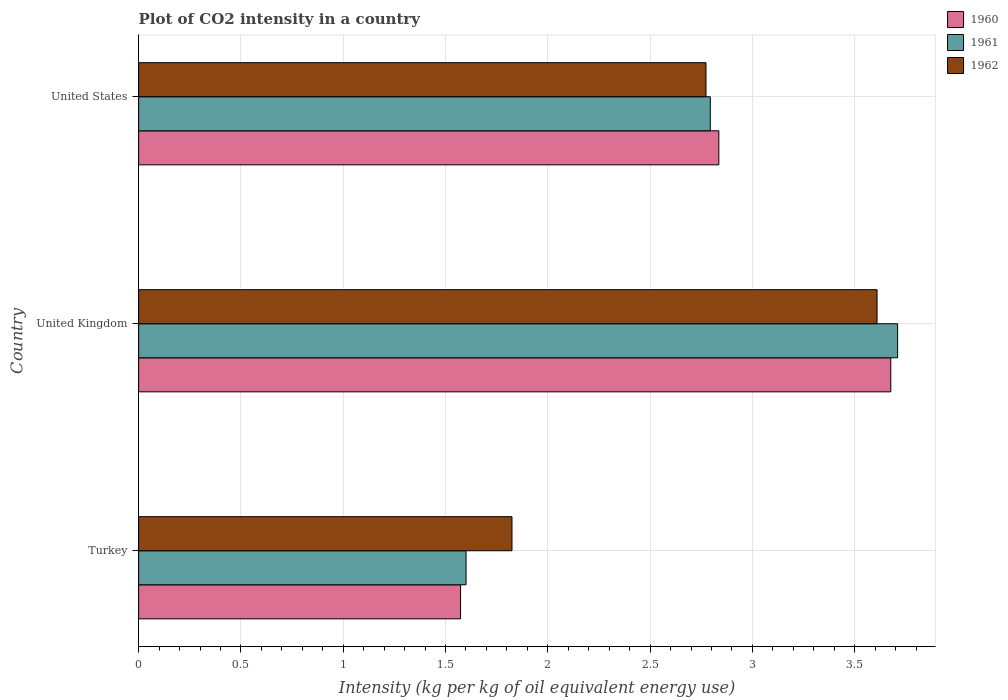How many different coloured bars are there?
Make the answer very short. 3. How many bars are there on the 3rd tick from the top?
Offer a very short reply. 3. In how many cases, is the number of bars for a given country not equal to the number of legend labels?
Make the answer very short. 0. What is the CO2 intensity in in 1961 in United States?
Ensure brevity in your answer.  2.79. Across all countries, what is the maximum CO2 intensity in in 1960?
Your answer should be compact. 3.68. Across all countries, what is the minimum CO2 intensity in in 1962?
Provide a succinct answer. 1.82. In which country was the CO2 intensity in in 1961 maximum?
Make the answer very short. United Kingdom. In which country was the CO2 intensity in in 1961 minimum?
Offer a very short reply. Turkey. What is the total CO2 intensity in in 1961 in the graph?
Give a very brief answer. 8.1. What is the difference between the CO2 intensity in in 1960 in United Kingdom and that in United States?
Give a very brief answer. 0.84. What is the difference between the CO2 intensity in in 1960 in United States and the CO2 intensity in in 1961 in Turkey?
Offer a very short reply. 1.24. What is the average CO2 intensity in in 1961 per country?
Make the answer very short. 2.7. What is the difference between the CO2 intensity in in 1960 and CO2 intensity in in 1962 in United Kingdom?
Ensure brevity in your answer.  0.07. What is the ratio of the CO2 intensity in in 1960 in Turkey to that in United Kingdom?
Give a very brief answer. 0.43. Is the CO2 intensity in in 1962 in United Kingdom less than that in United States?
Offer a very short reply. No. What is the difference between the highest and the second highest CO2 intensity in in 1961?
Your answer should be very brief. 0.92. What is the difference between the highest and the lowest CO2 intensity in in 1960?
Give a very brief answer. 2.1. In how many countries, is the CO2 intensity in in 1961 greater than the average CO2 intensity in in 1961 taken over all countries?
Give a very brief answer. 2. Is the sum of the CO2 intensity in in 1960 in Turkey and United Kingdom greater than the maximum CO2 intensity in in 1962 across all countries?
Make the answer very short. Yes. What does the 2nd bar from the bottom in Turkey represents?
Your answer should be very brief. 1961. What is the difference between two consecutive major ticks on the X-axis?
Keep it short and to the point. 0.5. Does the graph contain any zero values?
Your answer should be very brief. No. How many legend labels are there?
Your response must be concise. 3. How are the legend labels stacked?
Your answer should be compact. Vertical. What is the title of the graph?
Make the answer very short. Plot of CO2 intensity in a country. Does "1967" appear as one of the legend labels in the graph?
Provide a short and direct response. No. What is the label or title of the X-axis?
Offer a very short reply. Intensity (kg per kg of oil equivalent energy use). What is the label or title of the Y-axis?
Provide a short and direct response. Country. What is the Intensity (kg per kg of oil equivalent energy use) in 1960 in Turkey?
Give a very brief answer. 1.57. What is the Intensity (kg per kg of oil equivalent energy use) of 1961 in Turkey?
Give a very brief answer. 1.6. What is the Intensity (kg per kg of oil equivalent energy use) in 1962 in Turkey?
Your answer should be compact. 1.82. What is the Intensity (kg per kg of oil equivalent energy use) of 1960 in United Kingdom?
Offer a very short reply. 3.68. What is the Intensity (kg per kg of oil equivalent energy use) in 1961 in United Kingdom?
Your answer should be very brief. 3.71. What is the Intensity (kg per kg of oil equivalent energy use) in 1962 in United Kingdom?
Keep it short and to the point. 3.61. What is the Intensity (kg per kg of oil equivalent energy use) of 1960 in United States?
Offer a very short reply. 2.84. What is the Intensity (kg per kg of oil equivalent energy use) of 1961 in United States?
Make the answer very short. 2.79. What is the Intensity (kg per kg of oil equivalent energy use) of 1962 in United States?
Provide a succinct answer. 2.77. Across all countries, what is the maximum Intensity (kg per kg of oil equivalent energy use) in 1960?
Offer a very short reply. 3.68. Across all countries, what is the maximum Intensity (kg per kg of oil equivalent energy use) of 1961?
Give a very brief answer. 3.71. Across all countries, what is the maximum Intensity (kg per kg of oil equivalent energy use) of 1962?
Ensure brevity in your answer.  3.61. Across all countries, what is the minimum Intensity (kg per kg of oil equivalent energy use) in 1960?
Provide a succinct answer. 1.57. Across all countries, what is the minimum Intensity (kg per kg of oil equivalent energy use) of 1961?
Provide a succinct answer. 1.6. Across all countries, what is the minimum Intensity (kg per kg of oil equivalent energy use) of 1962?
Your answer should be compact. 1.82. What is the total Intensity (kg per kg of oil equivalent energy use) of 1960 in the graph?
Your answer should be compact. 8.09. What is the total Intensity (kg per kg of oil equivalent energy use) of 1961 in the graph?
Provide a short and direct response. 8.1. What is the total Intensity (kg per kg of oil equivalent energy use) of 1962 in the graph?
Offer a terse response. 8.21. What is the difference between the Intensity (kg per kg of oil equivalent energy use) in 1960 in Turkey and that in United Kingdom?
Provide a succinct answer. -2.1. What is the difference between the Intensity (kg per kg of oil equivalent energy use) of 1961 in Turkey and that in United Kingdom?
Ensure brevity in your answer.  -2.11. What is the difference between the Intensity (kg per kg of oil equivalent energy use) in 1962 in Turkey and that in United Kingdom?
Your response must be concise. -1.78. What is the difference between the Intensity (kg per kg of oil equivalent energy use) in 1960 in Turkey and that in United States?
Provide a short and direct response. -1.26. What is the difference between the Intensity (kg per kg of oil equivalent energy use) in 1961 in Turkey and that in United States?
Offer a terse response. -1.19. What is the difference between the Intensity (kg per kg of oil equivalent energy use) in 1962 in Turkey and that in United States?
Make the answer very short. -0.95. What is the difference between the Intensity (kg per kg of oil equivalent energy use) of 1960 in United Kingdom and that in United States?
Your answer should be compact. 0.84. What is the difference between the Intensity (kg per kg of oil equivalent energy use) in 1961 in United Kingdom and that in United States?
Offer a terse response. 0.92. What is the difference between the Intensity (kg per kg of oil equivalent energy use) of 1962 in United Kingdom and that in United States?
Your response must be concise. 0.84. What is the difference between the Intensity (kg per kg of oil equivalent energy use) in 1960 in Turkey and the Intensity (kg per kg of oil equivalent energy use) in 1961 in United Kingdom?
Provide a short and direct response. -2.14. What is the difference between the Intensity (kg per kg of oil equivalent energy use) of 1960 in Turkey and the Intensity (kg per kg of oil equivalent energy use) of 1962 in United Kingdom?
Give a very brief answer. -2.04. What is the difference between the Intensity (kg per kg of oil equivalent energy use) in 1961 in Turkey and the Intensity (kg per kg of oil equivalent energy use) in 1962 in United Kingdom?
Keep it short and to the point. -2.01. What is the difference between the Intensity (kg per kg of oil equivalent energy use) in 1960 in Turkey and the Intensity (kg per kg of oil equivalent energy use) in 1961 in United States?
Your answer should be very brief. -1.22. What is the difference between the Intensity (kg per kg of oil equivalent energy use) in 1960 in Turkey and the Intensity (kg per kg of oil equivalent energy use) in 1962 in United States?
Provide a succinct answer. -1.2. What is the difference between the Intensity (kg per kg of oil equivalent energy use) in 1961 in Turkey and the Intensity (kg per kg of oil equivalent energy use) in 1962 in United States?
Make the answer very short. -1.17. What is the difference between the Intensity (kg per kg of oil equivalent energy use) in 1960 in United Kingdom and the Intensity (kg per kg of oil equivalent energy use) in 1961 in United States?
Provide a short and direct response. 0.88. What is the difference between the Intensity (kg per kg of oil equivalent energy use) of 1960 in United Kingdom and the Intensity (kg per kg of oil equivalent energy use) of 1962 in United States?
Your response must be concise. 0.9. What is the difference between the Intensity (kg per kg of oil equivalent energy use) in 1961 in United Kingdom and the Intensity (kg per kg of oil equivalent energy use) in 1962 in United States?
Your answer should be compact. 0.94. What is the average Intensity (kg per kg of oil equivalent energy use) in 1960 per country?
Make the answer very short. 2.7. What is the average Intensity (kg per kg of oil equivalent energy use) in 1961 per country?
Your answer should be very brief. 2.7. What is the average Intensity (kg per kg of oil equivalent energy use) in 1962 per country?
Offer a terse response. 2.74. What is the difference between the Intensity (kg per kg of oil equivalent energy use) in 1960 and Intensity (kg per kg of oil equivalent energy use) in 1961 in Turkey?
Keep it short and to the point. -0.03. What is the difference between the Intensity (kg per kg of oil equivalent energy use) in 1960 and Intensity (kg per kg of oil equivalent energy use) in 1962 in Turkey?
Your response must be concise. -0.25. What is the difference between the Intensity (kg per kg of oil equivalent energy use) in 1961 and Intensity (kg per kg of oil equivalent energy use) in 1962 in Turkey?
Your answer should be compact. -0.22. What is the difference between the Intensity (kg per kg of oil equivalent energy use) in 1960 and Intensity (kg per kg of oil equivalent energy use) in 1961 in United Kingdom?
Your answer should be very brief. -0.03. What is the difference between the Intensity (kg per kg of oil equivalent energy use) in 1960 and Intensity (kg per kg of oil equivalent energy use) in 1962 in United Kingdom?
Offer a terse response. 0.07. What is the difference between the Intensity (kg per kg of oil equivalent energy use) of 1961 and Intensity (kg per kg of oil equivalent energy use) of 1962 in United Kingdom?
Offer a very short reply. 0.1. What is the difference between the Intensity (kg per kg of oil equivalent energy use) in 1960 and Intensity (kg per kg of oil equivalent energy use) in 1961 in United States?
Your response must be concise. 0.04. What is the difference between the Intensity (kg per kg of oil equivalent energy use) of 1960 and Intensity (kg per kg of oil equivalent energy use) of 1962 in United States?
Your answer should be compact. 0.06. What is the difference between the Intensity (kg per kg of oil equivalent energy use) of 1961 and Intensity (kg per kg of oil equivalent energy use) of 1962 in United States?
Your answer should be very brief. 0.02. What is the ratio of the Intensity (kg per kg of oil equivalent energy use) in 1960 in Turkey to that in United Kingdom?
Offer a very short reply. 0.43. What is the ratio of the Intensity (kg per kg of oil equivalent energy use) in 1961 in Turkey to that in United Kingdom?
Provide a short and direct response. 0.43. What is the ratio of the Intensity (kg per kg of oil equivalent energy use) of 1962 in Turkey to that in United Kingdom?
Make the answer very short. 0.51. What is the ratio of the Intensity (kg per kg of oil equivalent energy use) in 1960 in Turkey to that in United States?
Provide a short and direct response. 0.55. What is the ratio of the Intensity (kg per kg of oil equivalent energy use) in 1961 in Turkey to that in United States?
Make the answer very short. 0.57. What is the ratio of the Intensity (kg per kg of oil equivalent energy use) in 1962 in Turkey to that in United States?
Offer a very short reply. 0.66. What is the ratio of the Intensity (kg per kg of oil equivalent energy use) in 1960 in United Kingdom to that in United States?
Your answer should be compact. 1.3. What is the ratio of the Intensity (kg per kg of oil equivalent energy use) of 1961 in United Kingdom to that in United States?
Your response must be concise. 1.33. What is the ratio of the Intensity (kg per kg of oil equivalent energy use) of 1962 in United Kingdom to that in United States?
Offer a very short reply. 1.3. What is the difference between the highest and the second highest Intensity (kg per kg of oil equivalent energy use) of 1960?
Offer a very short reply. 0.84. What is the difference between the highest and the second highest Intensity (kg per kg of oil equivalent energy use) of 1961?
Your answer should be compact. 0.92. What is the difference between the highest and the second highest Intensity (kg per kg of oil equivalent energy use) in 1962?
Your answer should be very brief. 0.84. What is the difference between the highest and the lowest Intensity (kg per kg of oil equivalent energy use) in 1960?
Ensure brevity in your answer.  2.1. What is the difference between the highest and the lowest Intensity (kg per kg of oil equivalent energy use) in 1961?
Offer a very short reply. 2.11. What is the difference between the highest and the lowest Intensity (kg per kg of oil equivalent energy use) of 1962?
Provide a succinct answer. 1.78. 